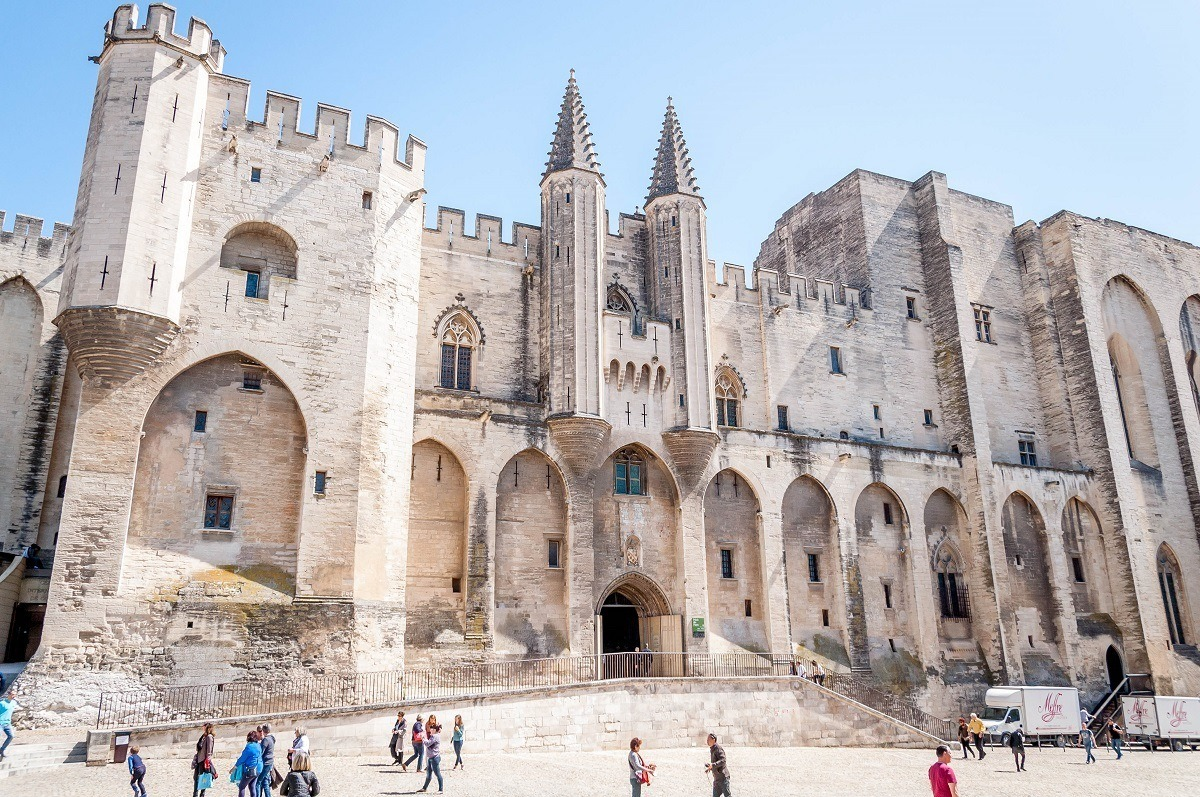Let's imagine this palace in a fantastical world. What kind of magical or mythical elements could it possess? In a fantastical realm, the Papal Palace could be a citadel of ancient magic, its towers topped with enchanted spires that glow with an ethereal light under the moon. The walls, composed of living stone, might be inscribed with runes that shift and change, containing powerful spells and ancient knowledge. At night, ghostly figures of past spiritual leaders may appear, offering wisdom and guiding lost souls. The grand arched entrance could be a portal to other mystical realms, requiring a special incantation to open. The gardens around the palace might contain rare, magical flora whose blossoms are used in potent potions and rituals. The palace itself could be guarded by mythical creatures, such as griffins or sentient gargoyles, adding to its aura of both splendor and trepidation. 